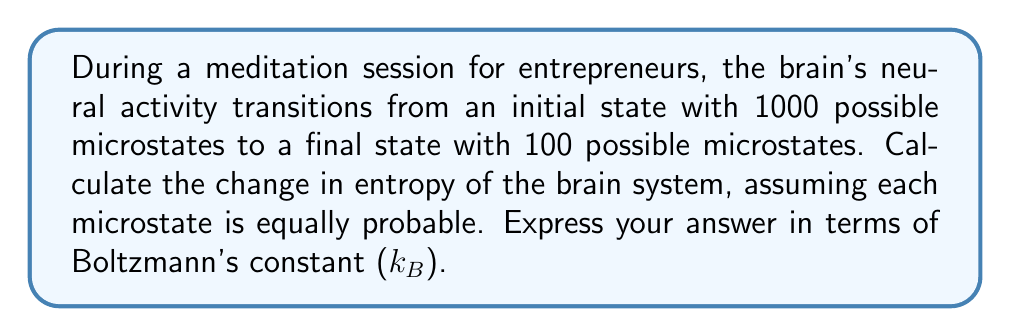Help me with this question. To solve this problem, we'll use the Boltzmann entropy formula and calculate the change in entropy:

1) The Boltzmann entropy formula is:
   $$S = k_B \ln W$$
   where $S$ is entropy, $k_B$ is Boltzmann's constant, and $W$ is the number of microstates.

2) Initial state (before meditation):
   $$S_i = k_B \ln(1000)$$

3) Final state (after meditation):
   $$S_f = k_B \ln(100)$$

4) Change in entropy:
   $$\Delta S = S_f - S_i$$
   
   $$\Delta S = k_B \ln(100) - k_B \ln(1000)$$

5) Using the logarithm property $\ln(a) - \ln(b) = \ln(a/b)$:
   $$\Delta S = k_B \ln(100/1000)$$
   
   $$\Delta S = k_B \ln(1/10)$$
   
   $$\Delta S = k_B \ln(0.1)$$

6) Since $\ln(0.1)$ is negative:
   $$\Delta S = -k_B \ln(10)$$

This negative change in entropy indicates a decrease in the system's disorder, which aligns with the calming effects of meditation on the brain.
Answer: $-k_B \ln(10)$ 